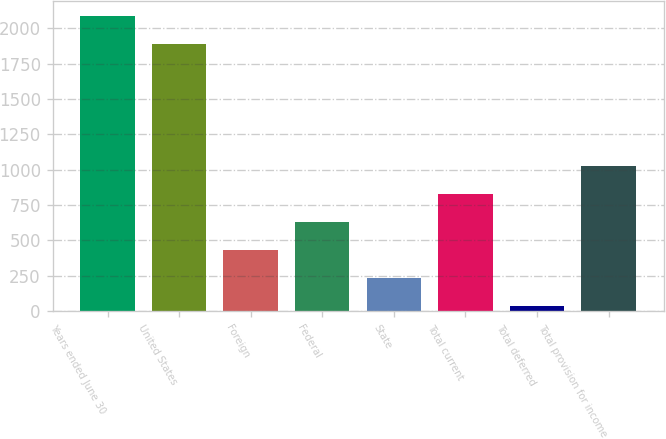Convert chart to OTSL. <chart><loc_0><loc_0><loc_500><loc_500><bar_chart><fcel>Years ended June 30<fcel>United States<fcel>Foreign<fcel>Federal<fcel>State<fcel>Total current<fcel>Total deferred<fcel>Total provision for income<nl><fcel>2085.99<fcel>1888.6<fcel>432.88<fcel>630.27<fcel>235.49<fcel>827.66<fcel>38.1<fcel>1025.05<nl></chart> 